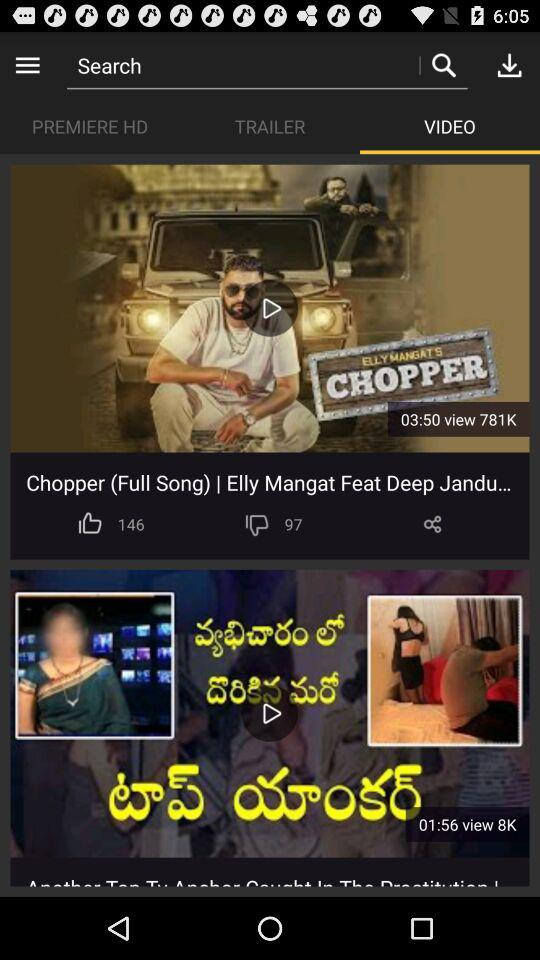How many likes did "Chopper (Full Song)" get? "Chopper (Full Song)" got 146 likes. 